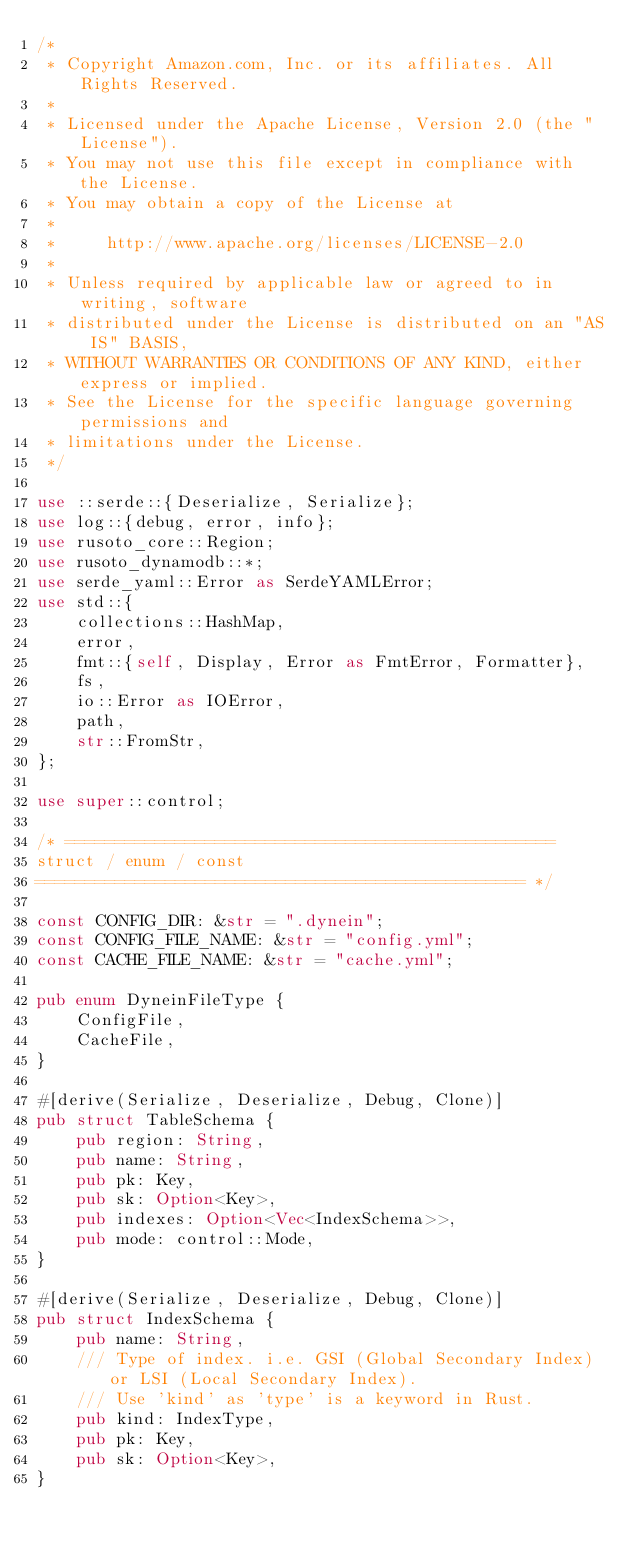Convert code to text. <code><loc_0><loc_0><loc_500><loc_500><_Rust_>/*
 * Copyright Amazon.com, Inc. or its affiliates. All Rights Reserved.
 *
 * Licensed under the Apache License, Version 2.0 (the "License").
 * You may not use this file except in compliance with the License.
 * You may obtain a copy of the License at
 *
 *     http://www.apache.org/licenses/LICENSE-2.0
 *
 * Unless required by applicable law or agreed to in writing, software
 * distributed under the License is distributed on an "AS IS" BASIS,
 * WITHOUT WARRANTIES OR CONDITIONS OF ANY KIND, either express or implied.
 * See the License for the specific language governing permissions and
 * limitations under the License.
 */

use ::serde::{Deserialize, Serialize};
use log::{debug, error, info};
use rusoto_core::Region;
use rusoto_dynamodb::*;
use serde_yaml::Error as SerdeYAMLError;
use std::{
    collections::HashMap,
    error,
    fmt::{self, Display, Error as FmtError, Formatter},
    fs,
    io::Error as IOError,
    path,
    str::FromStr,
};

use super::control;

/* =================================================
struct / enum / const
================================================= */

const CONFIG_DIR: &str = ".dynein";
const CONFIG_FILE_NAME: &str = "config.yml";
const CACHE_FILE_NAME: &str = "cache.yml";

pub enum DyneinFileType {
    ConfigFile,
    CacheFile,
}

#[derive(Serialize, Deserialize, Debug, Clone)]
pub struct TableSchema {
    pub region: String,
    pub name: String,
    pub pk: Key,
    pub sk: Option<Key>,
    pub indexes: Option<Vec<IndexSchema>>,
    pub mode: control::Mode,
}

#[derive(Serialize, Deserialize, Debug, Clone)]
pub struct IndexSchema {
    pub name: String,
    /// Type of index. i.e. GSI (Global Secondary Index) or LSI (Local Secondary Index).
    /// Use 'kind' as 'type' is a keyword in Rust.
    pub kind: IndexType,
    pub pk: Key,
    pub sk: Option<Key>,
}
</code> 